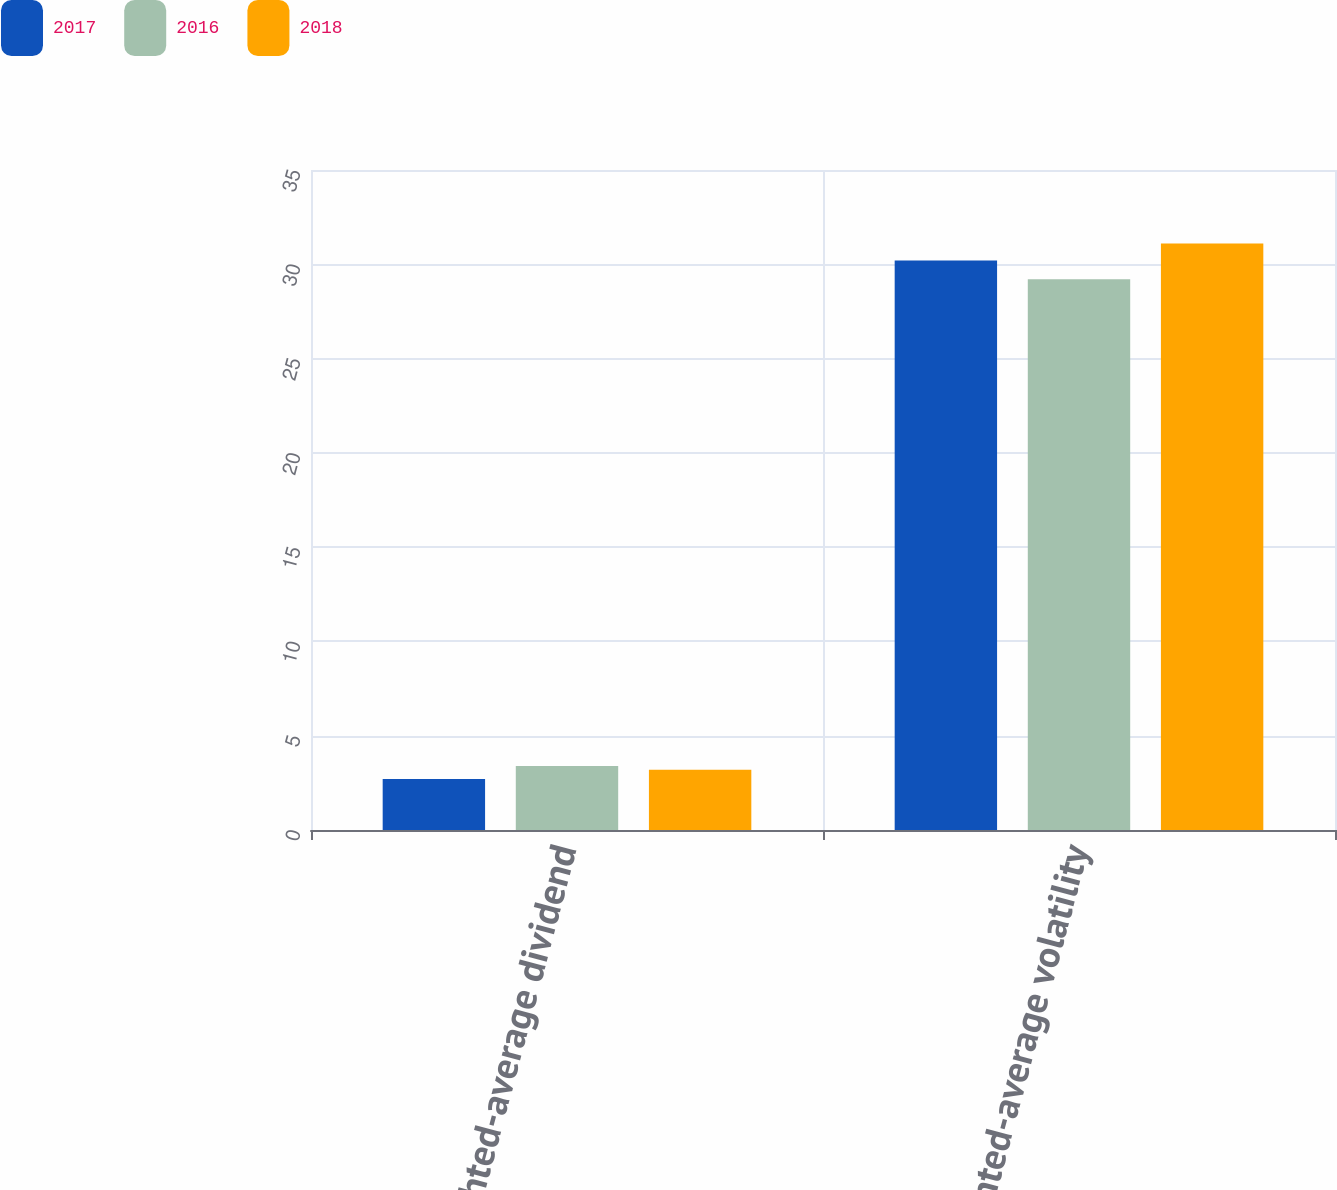Convert chart to OTSL. <chart><loc_0><loc_0><loc_500><loc_500><stacked_bar_chart><ecel><fcel>Weighted-average dividend<fcel>Weighted-average volatility<nl><fcel>2017<fcel>2.7<fcel>30.2<nl><fcel>2016<fcel>3.4<fcel>29.2<nl><fcel>2018<fcel>3.2<fcel>31.1<nl></chart> 